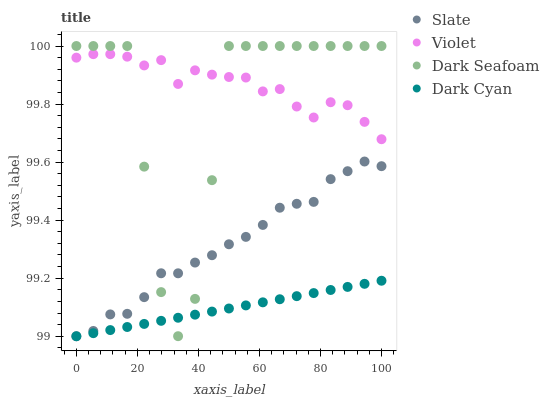Does Dark Cyan have the minimum area under the curve?
Answer yes or no. Yes. Does Violet have the maximum area under the curve?
Answer yes or no. Yes. Does Slate have the minimum area under the curve?
Answer yes or no. No. Does Slate have the maximum area under the curve?
Answer yes or no. No. Is Dark Cyan the smoothest?
Answer yes or no. Yes. Is Dark Seafoam the roughest?
Answer yes or no. Yes. Is Slate the smoothest?
Answer yes or no. No. Is Slate the roughest?
Answer yes or no. No. Does Dark Cyan have the lowest value?
Answer yes or no. Yes. Does Dark Seafoam have the lowest value?
Answer yes or no. No. Does Dark Seafoam have the highest value?
Answer yes or no. Yes. Does Slate have the highest value?
Answer yes or no. No. Is Dark Cyan less than Violet?
Answer yes or no. Yes. Is Violet greater than Dark Cyan?
Answer yes or no. Yes. Does Dark Seafoam intersect Dark Cyan?
Answer yes or no. Yes. Is Dark Seafoam less than Dark Cyan?
Answer yes or no. No. Is Dark Seafoam greater than Dark Cyan?
Answer yes or no. No. Does Dark Cyan intersect Violet?
Answer yes or no. No. 